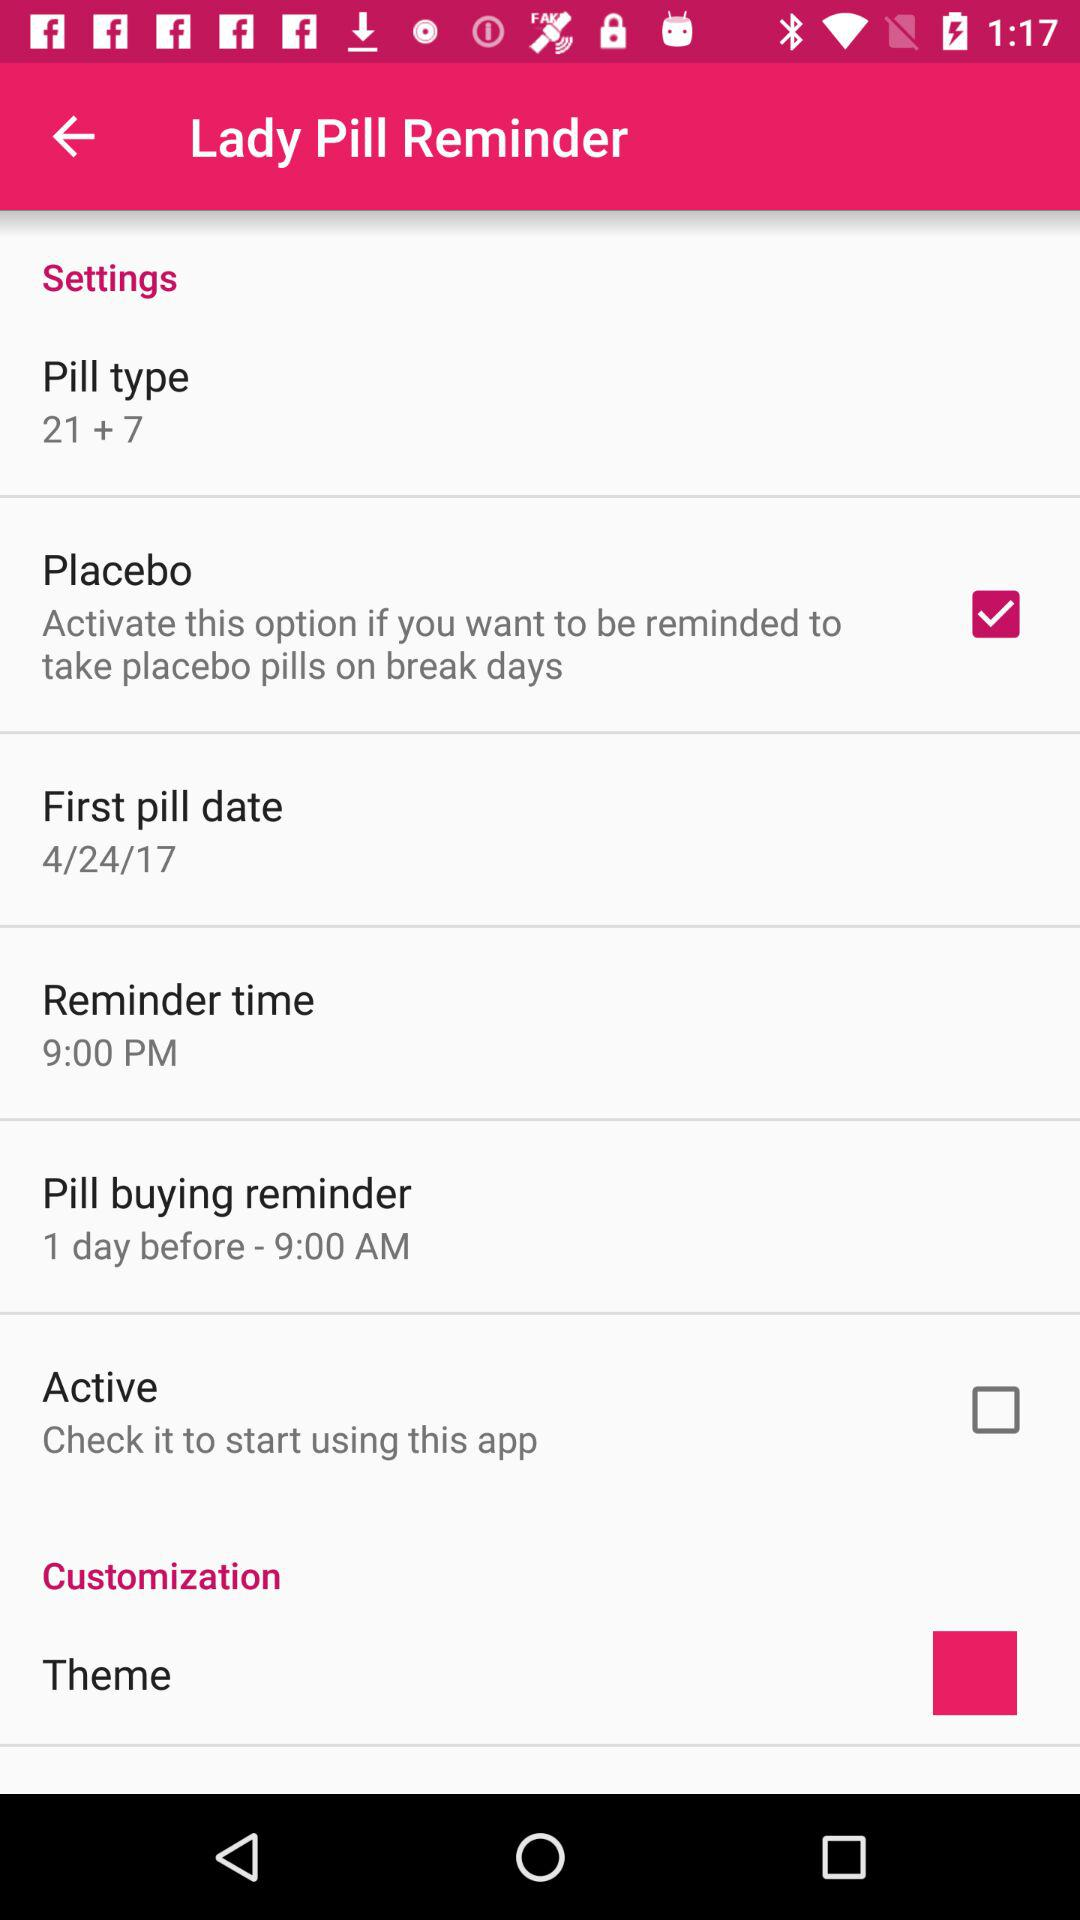What is the reminder time? The reminder time is 9:00 p.m. 